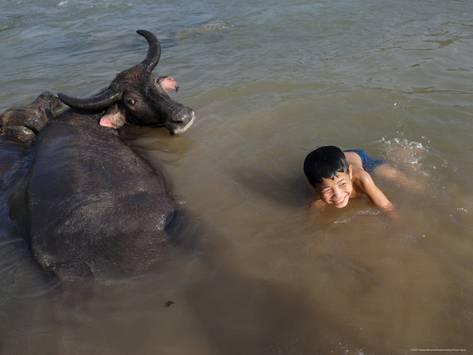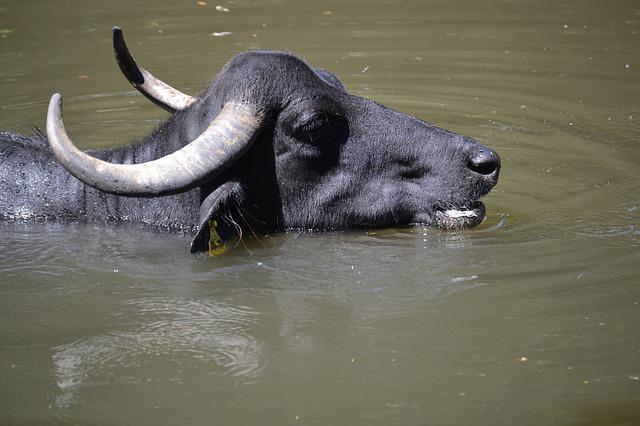The first image is the image on the left, the second image is the image on the right. Given the left and right images, does the statement "There is at least one human child in one of the images." hold true? Answer yes or no. Yes. The first image is the image on the left, the second image is the image on the right. Assess this claim about the two images: "At least one young boy is in the water near a water buffalo in one image.". Correct or not? Answer yes or no. Yes. 